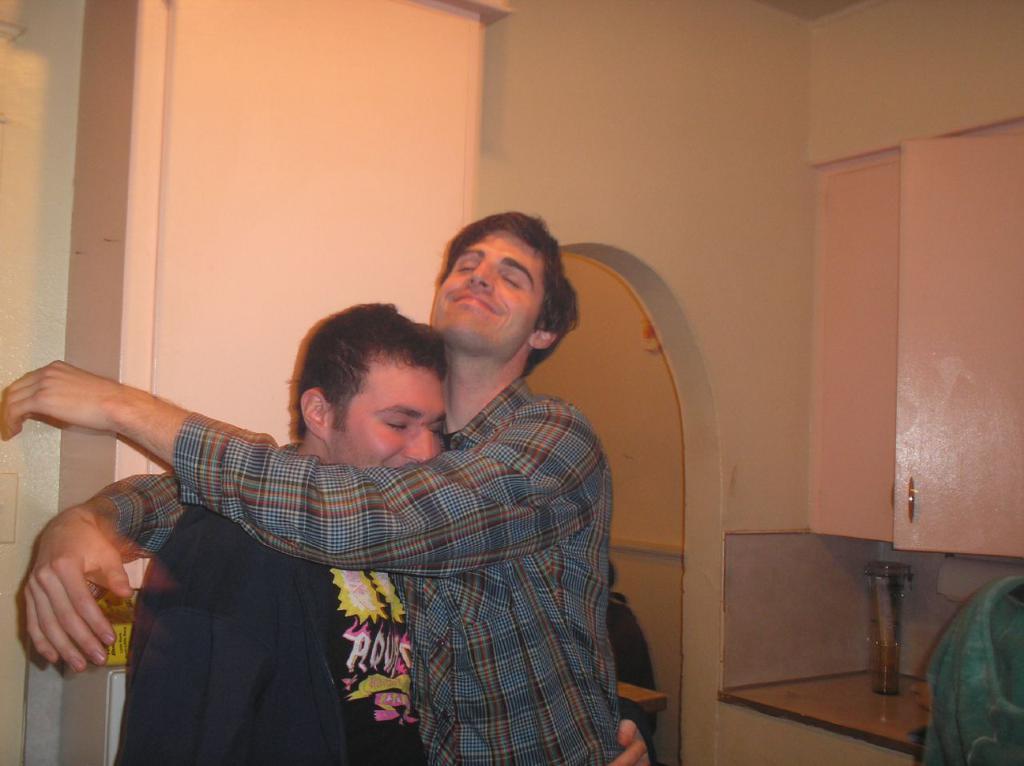How would you summarize this image in a sentence or two? In this image there are two people hugging each other. On the right side of the image there is some object on the platform. There is a cupboard. In the background of the image there is a wall. 